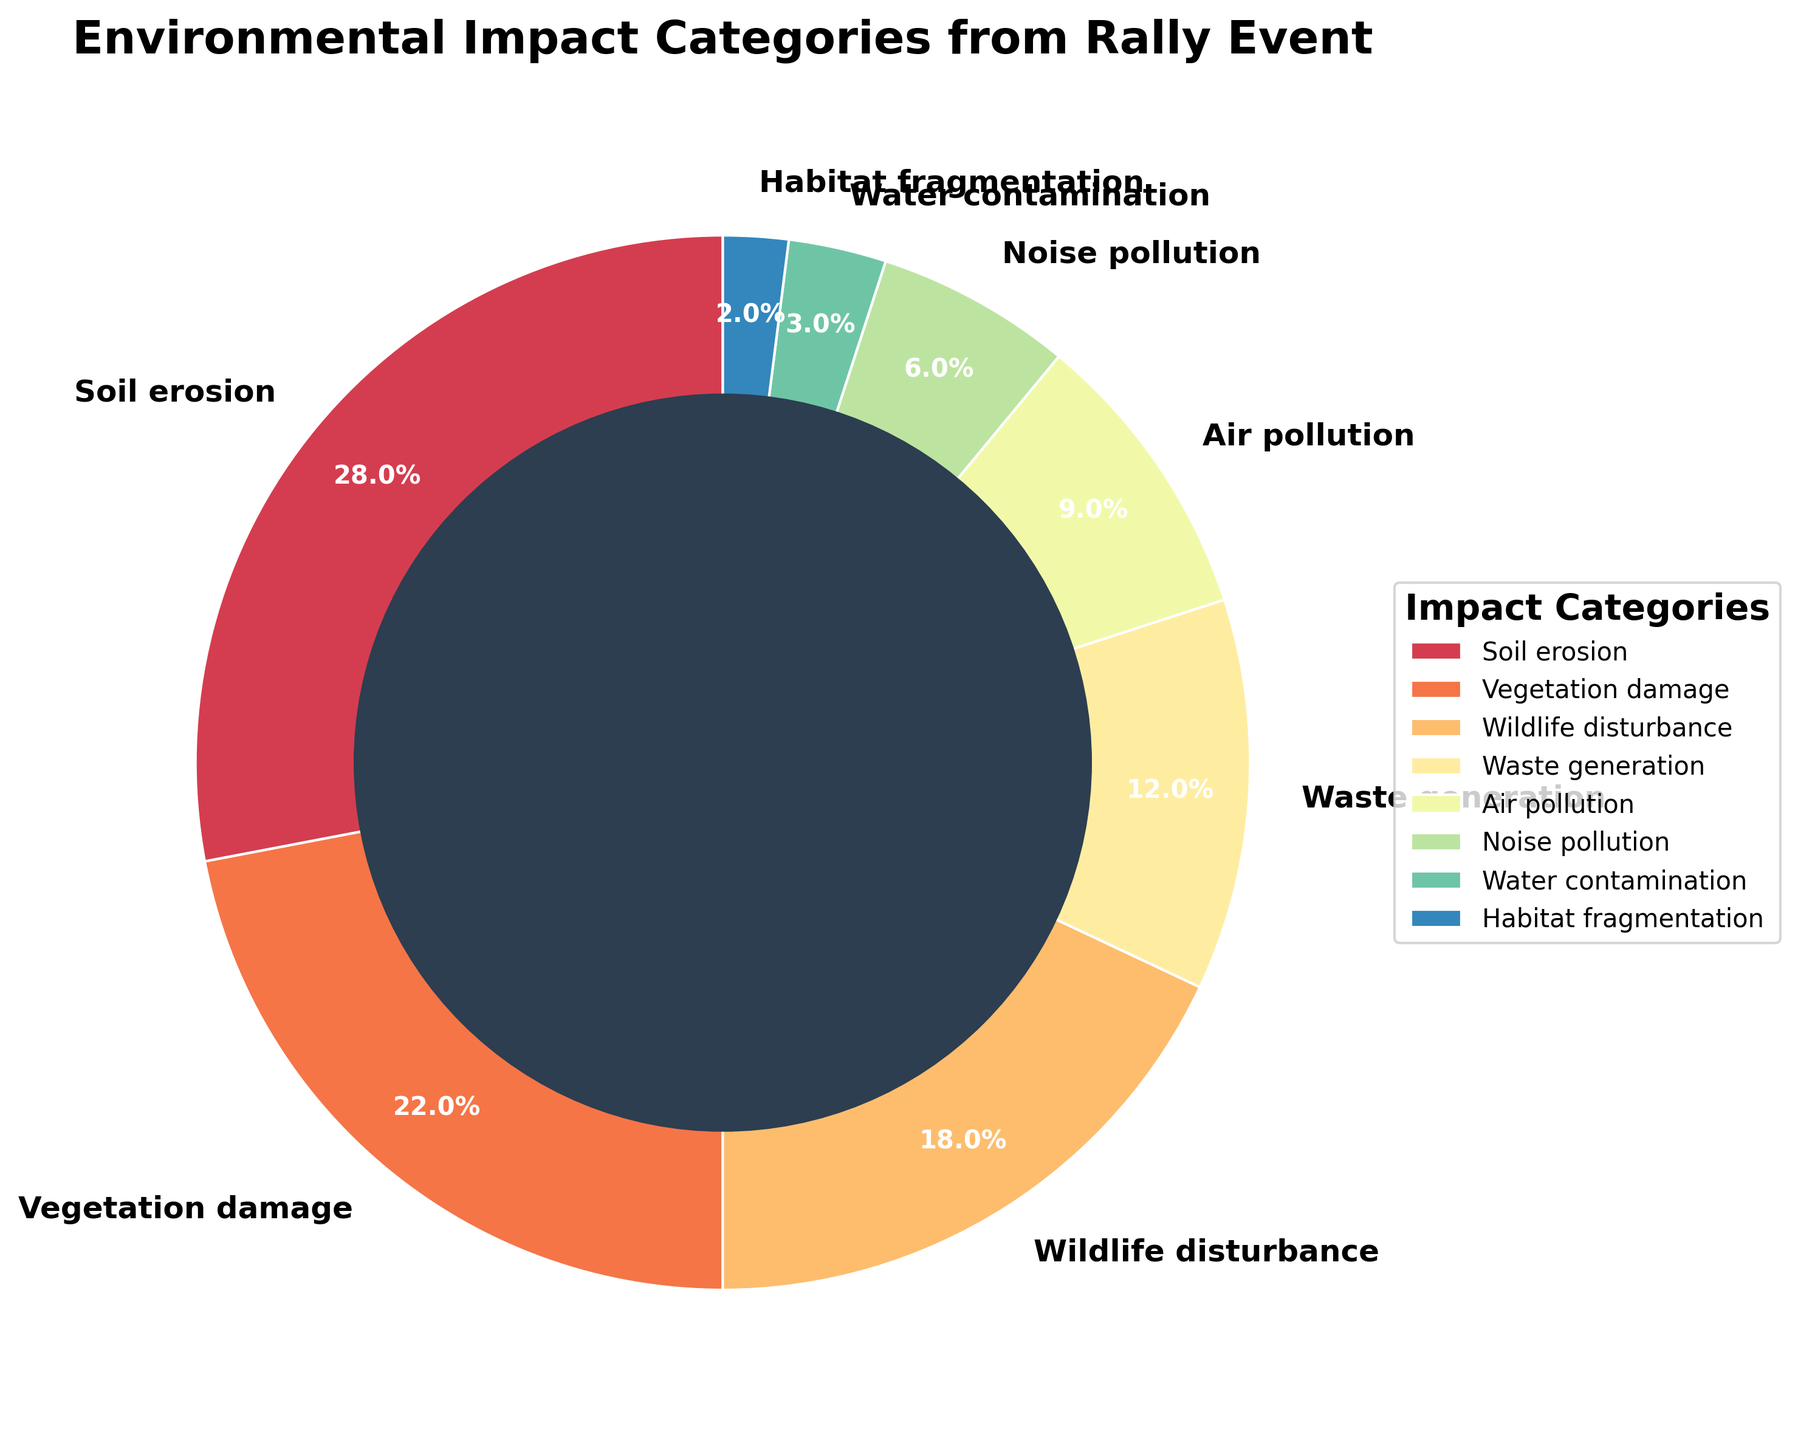What's the largest category of environmental impact from the rally event? The pie chart shows different categories with varying percentages. By looking at the slices, we see that the Soil erosion category has the largest slice at 28%
Answer: Soil erosion What's the combined percentage of Vegetation damage and Wildlife disturbance? First, find the percentages for these categories in the pie chart. Vegetation damage is 22% and Wildlife disturbance is 18%. Adding them gives 22% + 18% = 40%
Answer: 40% Which environmental impact category has the smallest percentage? The smallest slice in the pie chart represents Habitat fragmentation, and its corresponding percentage is 2%
Answer: Habitat fragmentation Is Noise pollution impact greater than Water contamination impact? By comparing the slices, we see Noise pollution is 6% while Water contamination is 3%. Since 6% > 3%, Noise pollution impact is greater
Answer: Yes Combine the percentages of all categories related to pollution (Air pollution, Noise pollution, Water contamination) The pie chart shows Air pollution (9%), Noise pollution (6%), and Water contamination (3%). Adding these gives 9% + 6% + 3% = 18%
Answer: 18% What's the difference in percentage between Soil erosion and Waste generation? Soil erosion is 28% and Waste generation is 12%. The difference is 28% - 12% = 16%
Answer: 16% Which is larger, the percentage of Air pollution or the combined percentage of Habitat fragmentation and Water contamination? Air pollution is 9%. Habitat fragmentation is 2% and Water contamination is 3%. Combined they are 2% + 3% = 5%. Since 9% > 5%, Air pollution is larger
Answer: Air pollution What is the percentage of the second largest environmental impact category? The second largest slice is Vegetation damage, which is 22%
Answer: 22% Sum up the percentages of the top three environmental impact categories The top three categories are Soil erosion (28%), Vegetation damage (22%), and Wildlife disturbance (18%). Adding them gives 28% + 22% + 18% = 68%
Answer: 68% Which impact category has a percentage that is less than 10% but more than 5%? From the slices, Noise pollution is 6%, which fits the criteria of being less than 10% but more than 5%
Answer: Noise pollution 